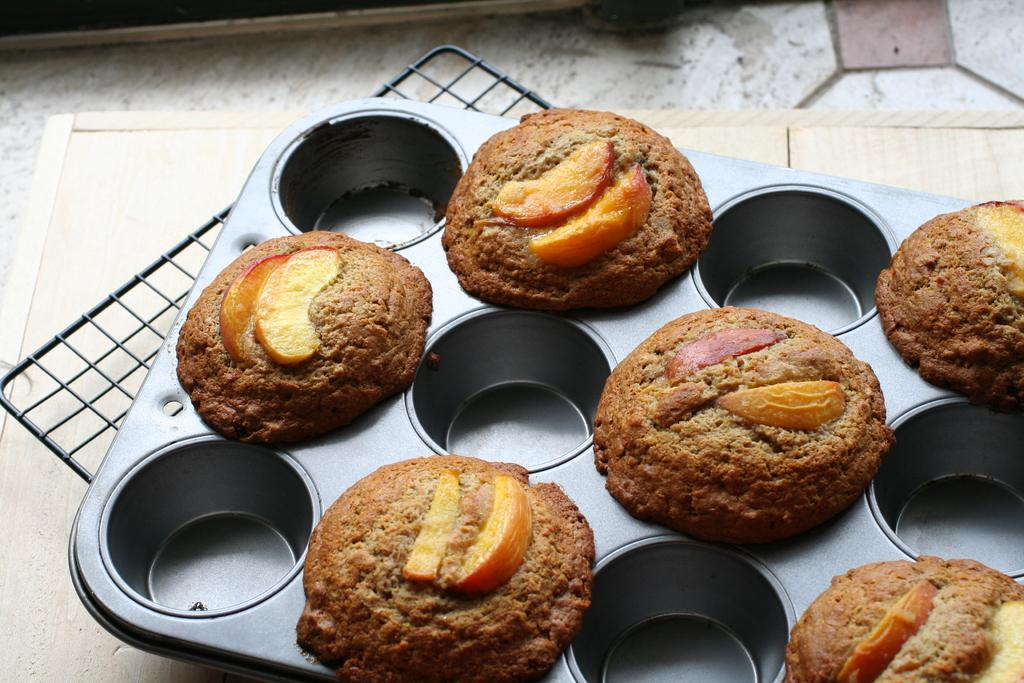Where was the image taken? The image was taken indoors. What can be seen at the top of the image? There is a floor visible at the top of the image. What is located at the bottom of the image? There is a table at the bottom of the image. Who is present in the image? There is a girl in the image. What is on the table in the image? There is a muffin mold with muffins in it in the image. What type of texture can be seen on the doll's clothing in the image? There are no dolls present in the image, so there is no doll's clothing to describe. How many teeth can be seen in the image? There are no teeth visible in the image. 